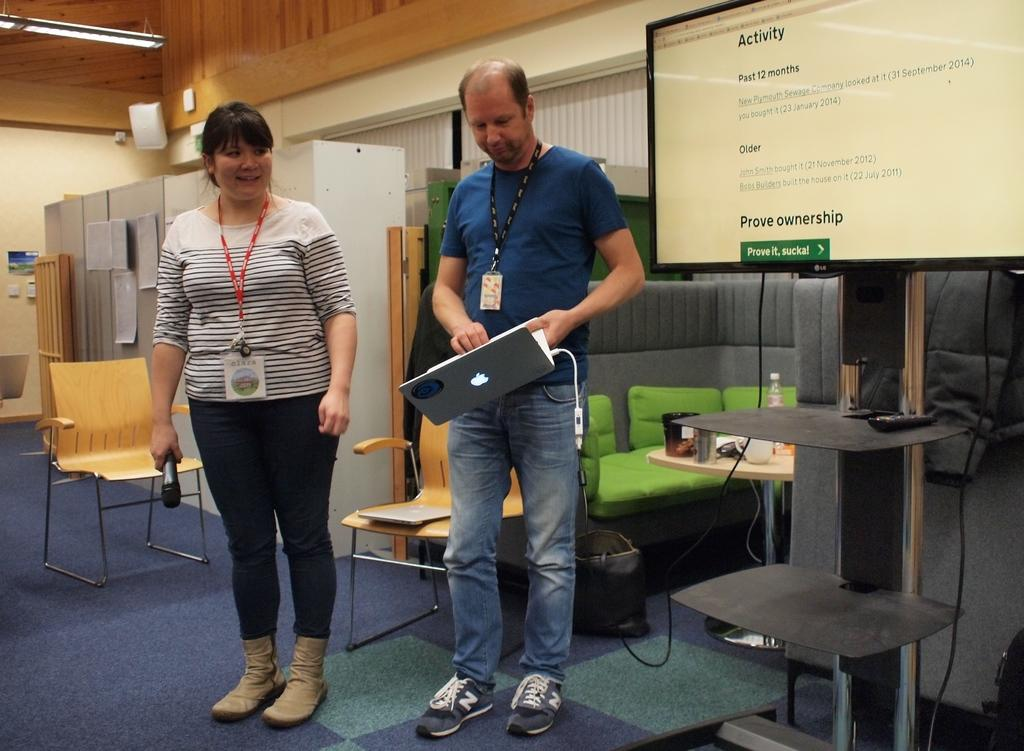What is the man in the image holding? The man is holding a laptop. What is the woman in the image holding? The woman is holding a microphone. What can be seen in the background of the image? There are chairs and a couch in the background of the image. What type of music can be heard coming from the land in the image? There is no reference to land or music in the image, so it's not possible to determine what, if any, music might be heard. 